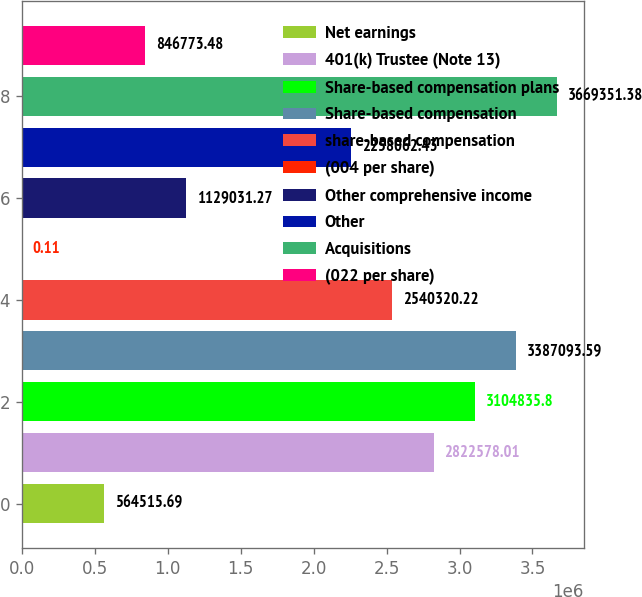Convert chart. <chart><loc_0><loc_0><loc_500><loc_500><bar_chart><fcel>Net earnings<fcel>401(k) Trustee (Note 13)<fcel>Share-based compensation plans<fcel>Share-based compensation<fcel>share-based compensation<fcel>(004 per share)<fcel>Other comprehensive income<fcel>Other<fcel>Acquisitions<fcel>(022 per share)<nl><fcel>564516<fcel>2.82258e+06<fcel>3.10484e+06<fcel>3.38709e+06<fcel>2.54032e+06<fcel>0.11<fcel>1.12903e+06<fcel>2.25806e+06<fcel>3.66935e+06<fcel>846773<nl></chart> 